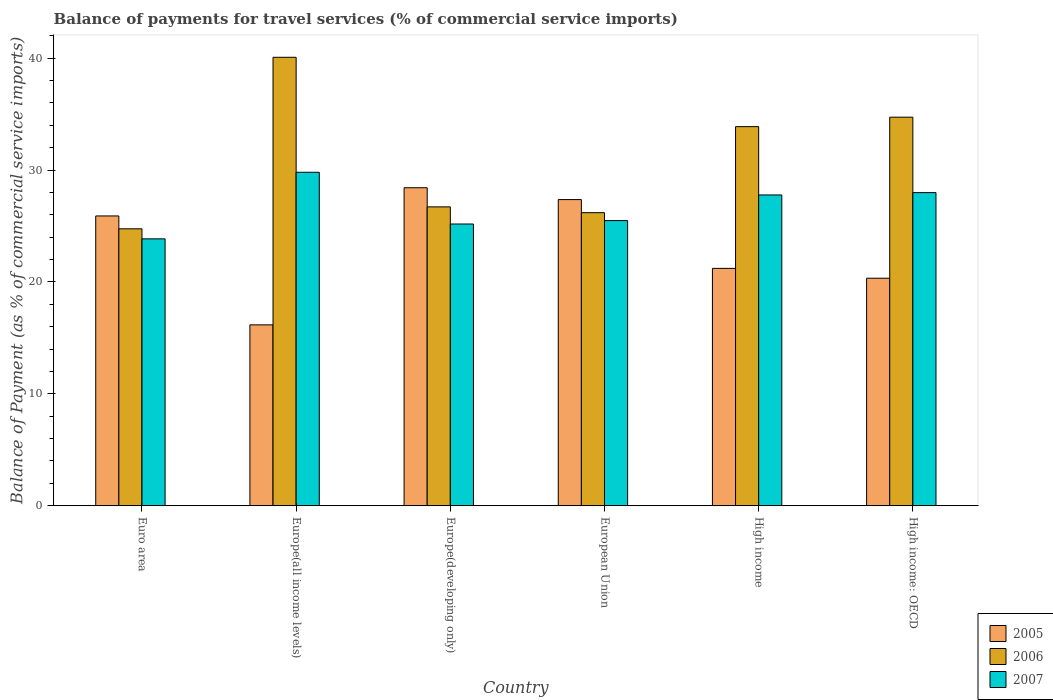How many groups of bars are there?
Give a very brief answer. 6. What is the label of the 5th group of bars from the left?
Make the answer very short. High income. What is the balance of payments for travel services in 2006 in Euro area?
Ensure brevity in your answer.  24.75. Across all countries, what is the maximum balance of payments for travel services in 2005?
Your response must be concise. 28.42. Across all countries, what is the minimum balance of payments for travel services in 2005?
Your response must be concise. 16.16. In which country was the balance of payments for travel services in 2006 maximum?
Make the answer very short. Europe(all income levels). In which country was the balance of payments for travel services in 2007 minimum?
Your response must be concise. Euro area. What is the total balance of payments for travel services in 2006 in the graph?
Provide a short and direct response. 186.31. What is the difference between the balance of payments for travel services in 2006 in Euro area and that in European Union?
Your answer should be very brief. -1.44. What is the difference between the balance of payments for travel services in 2006 in High income: OECD and the balance of payments for travel services in 2007 in Europe(all income levels)?
Your answer should be compact. 4.92. What is the average balance of payments for travel services in 2007 per country?
Give a very brief answer. 26.67. What is the difference between the balance of payments for travel services of/in 2006 and balance of payments for travel services of/in 2005 in Europe(all income levels)?
Your response must be concise. 23.91. What is the ratio of the balance of payments for travel services in 2005 in Europe(developing only) to that in High income: OECD?
Provide a succinct answer. 1.4. What is the difference between the highest and the second highest balance of payments for travel services in 2007?
Provide a succinct answer. -0.21. What is the difference between the highest and the lowest balance of payments for travel services in 2007?
Ensure brevity in your answer.  5.95. What does the 1st bar from the left in High income represents?
Your answer should be compact. 2005. How many bars are there?
Your response must be concise. 18. How many countries are there in the graph?
Your answer should be very brief. 6. What is the difference between two consecutive major ticks on the Y-axis?
Your response must be concise. 10. Are the values on the major ticks of Y-axis written in scientific E-notation?
Your response must be concise. No. Does the graph contain grids?
Provide a succinct answer. No. What is the title of the graph?
Your response must be concise. Balance of payments for travel services (% of commercial service imports). Does "1995" appear as one of the legend labels in the graph?
Your response must be concise. No. What is the label or title of the X-axis?
Your response must be concise. Country. What is the label or title of the Y-axis?
Your answer should be compact. Balance of Payment (as % of commercial service imports). What is the Balance of Payment (as % of commercial service imports) in 2005 in Euro area?
Offer a terse response. 25.89. What is the Balance of Payment (as % of commercial service imports) of 2006 in Euro area?
Your answer should be very brief. 24.75. What is the Balance of Payment (as % of commercial service imports) in 2007 in Euro area?
Make the answer very short. 23.85. What is the Balance of Payment (as % of commercial service imports) of 2005 in Europe(all income levels)?
Provide a succinct answer. 16.16. What is the Balance of Payment (as % of commercial service imports) in 2006 in Europe(all income levels)?
Make the answer very short. 40.07. What is the Balance of Payment (as % of commercial service imports) of 2007 in Europe(all income levels)?
Provide a short and direct response. 29.8. What is the Balance of Payment (as % of commercial service imports) in 2005 in Europe(developing only)?
Your response must be concise. 28.42. What is the Balance of Payment (as % of commercial service imports) in 2006 in Europe(developing only)?
Make the answer very short. 26.71. What is the Balance of Payment (as % of commercial service imports) in 2007 in Europe(developing only)?
Keep it short and to the point. 25.17. What is the Balance of Payment (as % of commercial service imports) in 2005 in European Union?
Your answer should be compact. 27.36. What is the Balance of Payment (as % of commercial service imports) in 2006 in European Union?
Offer a terse response. 26.19. What is the Balance of Payment (as % of commercial service imports) in 2007 in European Union?
Provide a succinct answer. 25.48. What is the Balance of Payment (as % of commercial service imports) in 2005 in High income?
Keep it short and to the point. 21.21. What is the Balance of Payment (as % of commercial service imports) of 2006 in High income?
Make the answer very short. 33.88. What is the Balance of Payment (as % of commercial service imports) in 2007 in High income?
Your response must be concise. 27.77. What is the Balance of Payment (as % of commercial service imports) of 2005 in High income: OECD?
Ensure brevity in your answer.  20.33. What is the Balance of Payment (as % of commercial service imports) of 2006 in High income: OECD?
Ensure brevity in your answer.  34.72. What is the Balance of Payment (as % of commercial service imports) of 2007 in High income: OECD?
Offer a terse response. 27.98. Across all countries, what is the maximum Balance of Payment (as % of commercial service imports) in 2005?
Your answer should be very brief. 28.42. Across all countries, what is the maximum Balance of Payment (as % of commercial service imports) in 2006?
Offer a very short reply. 40.07. Across all countries, what is the maximum Balance of Payment (as % of commercial service imports) in 2007?
Your answer should be compact. 29.8. Across all countries, what is the minimum Balance of Payment (as % of commercial service imports) of 2005?
Ensure brevity in your answer.  16.16. Across all countries, what is the minimum Balance of Payment (as % of commercial service imports) of 2006?
Give a very brief answer. 24.75. Across all countries, what is the minimum Balance of Payment (as % of commercial service imports) in 2007?
Offer a very short reply. 23.85. What is the total Balance of Payment (as % of commercial service imports) in 2005 in the graph?
Make the answer very short. 139.37. What is the total Balance of Payment (as % of commercial service imports) of 2006 in the graph?
Offer a very short reply. 186.31. What is the total Balance of Payment (as % of commercial service imports) in 2007 in the graph?
Provide a succinct answer. 160.05. What is the difference between the Balance of Payment (as % of commercial service imports) of 2005 in Euro area and that in Europe(all income levels)?
Give a very brief answer. 9.73. What is the difference between the Balance of Payment (as % of commercial service imports) of 2006 in Euro area and that in Europe(all income levels)?
Your response must be concise. -15.33. What is the difference between the Balance of Payment (as % of commercial service imports) in 2007 in Euro area and that in Europe(all income levels)?
Provide a short and direct response. -5.95. What is the difference between the Balance of Payment (as % of commercial service imports) in 2005 in Euro area and that in Europe(developing only)?
Offer a very short reply. -2.52. What is the difference between the Balance of Payment (as % of commercial service imports) in 2006 in Euro area and that in Europe(developing only)?
Your answer should be very brief. -1.96. What is the difference between the Balance of Payment (as % of commercial service imports) in 2007 in Euro area and that in Europe(developing only)?
Provide a succinct answer. -1.33. What is the difference between the Balance of Payment (as % of commercial service imports) in 2005 in Euro area and that in European Union?
Your answer should be very brief. -1.46. What is the difference between the Balance of Payment (as % of commercial service imports) of 2006 in Euro area and that in European Union?
Give a very brief answer. -1.44. What is the difference between the Balance of Payment (as % of commercial service imports) in 2007 in Euro area and that in European Union?
Your response must be concise. -1.63. What is the difference between the Balance of Payment (as % of commercial service imports) of 2005 in Euro area and that in High income?
Your response must be concise. 4.68. What is the difference between the Balance of Payment (as % of commercial service imports) in 2006 in Euro area and that in High income?
Provide a succinct answer. -9.13. What is the difference between the Balance of Payment (as % of commercial service imports) in 2007 in Euro area and that in High income?
Your answer should be very brief. -3.92. What is the difference between the Balance of Payment (as % of commercial service imports) in 2005 in Euro area and that in High income: OECD?
Give a very brief answer. 5.56. What is the difference between the Balance of Payment (as % of commercial service imports) in 2006 in Euro area and that in High income: OECD?
Ensure brevity in your answer.  -9.97. What is the difference between the Balance of Payment (as % of commercial service imports) of 2007 in Euro area and that in High income: OECD?
Your answer should be compact. -4.13. What is the difference between the Balance of Payment (as % of commercial service imports) in 2005 in Europe(all income levels) and that in Europe(developing only)?
Give a very brief answer. -12.25. What is the difference between the Balance of Payment (as % of commercial service imports) of 2006 in Europe(all income levels) and that in Europe(developing only)?
Ensure brevity in your answer.  13.37. What is the difference between the Balance of Payment (as % of commercial service imports) in 2007 in Europe(all income levels) and that in Europe(developing only)?
Ensure brevity in your answer.  4.62. What is the difference between the Balance of Payment (as % of commercial service imports) of 2005 in Europe(all income levels) and that in European Union?
Make the answer very short. -11.2. What is the difference between the Balance of Payment (as % of commercial service imports) of 2006 in Europe(all income levels) and that in European Union?
Provide a succinct answer. 13.88. What is the difference between the Balance of Payment (as % of commercial service imports) in 2007 in Europe(all income levels) and that in European Union?
Your answer should be very brief. 4.32. What is the difference between the Balance of Payment (as % of commercial service imports) of 2005 in Europe(all income levels) and that in High income?
Make the answer very short. -5.05. What is the difference between the Balance of Payment (as % of commercial service imports) in 2006 in Europe(all income levels) and that in High income?
Offer a very short reply. 6.2. What is the difference between the Balance of Payment (as % of commercial service imports) in 2007 in Europe(all income levels) and that in High income?
Make the answer very short. 2.03. What is the difference between the Balance of Payment (as % of commercial service imports) of 2005 in Europe(all income levels) and that in High income: OECD?
Keep it short and to the point. -4.17. What is the difference between the Balance of Payment (as % of commercial service imports) of 2006 in Europe(all income levels) and that in High income: OECD?
Make the answer very short. 5.35. What is the difference between the Balance of Payment (as % of commercial service imports) in 2007 in Europe(all income levels) and that in High income: OECD?
Provide a succinct answer. 1.82. What is the difference between the Balance of Payment (as % of commercial service imports) in 2005 in Europe(developing only) and that in European Union?
Your answer should be compact. 1.06. What is the difference between the Balance of Payment (as % of commercial service imports) of 2006 in Europe(developing only) and that in European Union?
Give a very brief answer. 0.52. What is the difference between the Balance of Payment (as % of commercial service imports) of 2007 in Europe(developing only) and that in European Union?
Offer a terse response. -0.31. What is the difference between the Balance of Payment (as % of commercial service imports) in 2005 in Europe(developing only) and that in High income?
Your answer should be very brief. 7.21. What is the difference between the Balance of Payment (as % of commercial service imports) in 2006 in Europe(developing only) and that in High income?
Make the answer very short. -7.17. What is the difference between the Balance of Payment (as % of commercial service imports) of 2007 in Europe(developing only) and that in High income?
Your response must be concise. -2.6. What is the difference between the Balance of Payment (as % of commercial service imports) of 2005 in Europe(developing only) and that in High income: OECD?
Provide a succinct answer. 8.08. What is the difference between the Balance of Payment (as % of commercial service imports) in 2006 in Europe(developing only) and that in High income: OECD?
Offer a terse response. -8.01. What is the difference between the Balance of Payment (as % of commercial service imports) in 2007 in Europe(developing only) and that in High income: OECD?
Provide a succinct answer. -2.8. What is the difference between the Balance of Payment (as % of commercial service imports) of 2005 in European Union and that in High income?
Provide a succinct answer. 6.15. What is the difference between the Balance of Payment (as % of commercial service imports) of 2006 in European Union and that in High income?
Offer a very short reply. -7.69. What is the difference between the Balance of Payment (as % of commercial service imports) in 2007 in European Union and that in High income?
Make the answer very short. -2.29. What is the difference between the Balance of Payment (as % of commercial service imports) in 2005 in European Union and that in High income: OECD?
Ensure brevity in your answer.  7.03. What is the difference between the Balance of Payment (as % of commercial service imports) in 2006 in European Union and that in High income: OECD?
Your answer should be compact. -8.53. What is the difference between the Balance of Payment (as % of commercial service imports) of 2007 in European Union and that in High income: OECD?
Offer a very short reply. -2.5. What is the difference between the Balance of Payment (as % of commercial service imports) in 2005 in High income and that in High income: OECD?
Provide a succinct answer. 0.88. What is the difference between the Balance of Payment (as % of commercial service imports) of 2006 in High income and that in High income: OECD?
Ensure brevity in your answer.  -0.84. What is the difference between the Balance of Payment (as % of commercial service imports) in 2007 in High income and that in High income: OECD?
Your response must be concise. -0.21. What is the difference between the Balance of Payment (as % of commercial service imports) of 2005 in Euro area and the Balance of Payment (as % of commercial service imports) of 2006 in Europe(all income levels)?
Ensure brevity in your answer.  -14.18. What is the difference between the Balance of Payment (as % of commercial service imports) in 2005 in Euro area and the Balance of Payment (as % of commercial service imports) in 2007 in Europe(all income levels)?
Give a very brief answer. -3.9. What is the difference between the Balance of Payment (as % of commercial service imports) in 2006 in Euro area and the Balance of Payment (as % of commercial service imports) in 2007 in Europe(all income levels)?
Your answer should be compact. -5.05. What is the difference between the Balance of Payment (as % of commercial service imports) of 2005 in Euro area and the Balance of Payment (as % of commercial service imports) of 2006 in Europe(developing only)?
Offer a very short reply. -0.81. What is the difference between the Balance of Payment (as % of commercial service imports) in 2005 in Euro area and the Balance of Payment (as % of commercial service imports) in 2007 in Europe(developing only)?
Offer a terse response. 0.72. What is the difference between the Balance of Payment (as % of commercial service imports) of 2006 in Euro area and the Balance of Payment (as % of commercial service imports) of 2007 in Europe(developing only)?
Your response must be concise. -0.43. What is the difference between the Balance of Payment (as % of commercial service imports) in 2005 in Euro area and the Balance of Payment (as % of commercial service imports) in 2006 in European Union?
Make the answer very short. -0.29. What is the difference between the Balance of Payment (as % of commercial service imports) in 2005 in Euro area and the Balance of Payment (as % of commercial service imports) in 2007 in European Union?
Your answer should be compact. 0.41. What is the difference between the Balance of Payment (as % of commercial service imports) in 2006 in Euro area and the Balance of Payment (as % of commercial service imports) in 2007 in European Union?
Provide a succinct answer. -0.73. What is the difference between the Balance of Payment (as % of commercial service imports) of 2005 in Euro area and the Balance of Payment (as % of commercial service imports) of 2006 in High income?
Your answer should be compact. -7.98. What is the difference between the Balance of Payment (as % of commercial service imports) of 2005 in Euro area and the Balance of Payment (as % of commercial service imports) of 2007 in High income?
Make the answer very short. -1.88. What is the difference between the Balance of Payment (as % of commercial service imports) in 2006 in Euro area and the Balance of Payment (as % of commercial service imports) in 2007 in High income?
Keep it short and to the point. -3.02. What is the difference between the Balance of Payment (as % of commercial service imports) of 2005 in Euro area and the Balance of Payment (as % of commercial service imports) of 2006 in High income: OECD?
Provide a succinct answer. -8.83. What is the difference between the Balance of Payment (as % of commercial service imports) in 2005 in Euro area and the Balance of Payment (as % of commercial service imports) in 2007 in High income: OECD?
Your response must be concise. -2.09. What is the difference between the Balance of Payment (as % of commercial service imports) in 2006 in Euro area and the Balance of Payment (as % of commercial service imports) in 2007 in High income: OECD?
Provide a short and direct response. -3.23. What is the difference between the Balance of Payment (as % of commercial service imports) in 2005 in Europe(all income levels) and the Balance of Payment (as % of commercial service imports) in 2006 in Europe(developing only)?
Your response must be concise. -10.55. What is the difference between the Balance of Payment (as % of commercial service imports) of 2005 in Europe(all income levels) and the Balance of Payment (as % of commercial service imports) of 2007 in Europe(developing only)?
Offer a terse response. -9.01. What is the difference between the Balance of Payment (as % of commercial service imports) in 2006 in Europe(all income levels) and the Balance of Payment (as % of commercial service imports) in 2007 in Europe(developing only)?
Offer a very short reply. 14.9. What is the difference between the Balance of Payment (as % of commercial service imports) in 2005 in Europe(all income levels) and the Balance of Payment (as % of commercial service imports) in 2006 in European Union?
Provide a succinct answer. -10.03. What is the difference between the Balance of Payment (as % of commercial service imports) in 2005 in Europe(all income levels) and the Balance of Payment (as % of commercial service imports) in 2007 in European Union?
Offer a very short reply. -9.32. What is the difference between the Balance of Payment (as % of commercial service imports) of 2006 in Europe(all income levels) and the Balance of Payment (as % of commercial service imports) of 2007 in European Union?
Provide a succinct answer. 14.59. What is the difference between the Balance of Payment (as % of commercial service imports) in 2005 in Europe(all income levels) and the Balance of Payment (as % of commercial service imports) in 2006 in High income?
Your answer should be compact. -17.71. What is the difference between the Balance of Payment (as % of commercial service imports) in 2005 in Europe(all income levels) and the Balance of Payment (as % of commercial service imports) in 2007 in High income?
Offer a very short reply. -11.61. What is the difference between the Balance of Payment (as % of commercial service imports) in 2006 in Europe(all income levels) and the Balance of Payment (as % of commercial service imports) in 2007 in High income?
Give a very brief answer. 12.3. What is the difference between the Balance of Payment (as % of commercial service imports) in 2005 in Europe(all income levels) and the Balance of Payment (as % of commercial service imports) in 2006 in High income: OECD?
Make the answer very short. -18.56. What is the difference between the Balance of Payment (as % of commercial service imports) in 2005 in Europe(all income levels) and the Balance of Payment (as % of commercial service imports) in 2007 in High income: OECD?
Ensure brevity in your answer.  -11.82. What is the difference between the Balance of Payment (as % of commercial service imports) of 2006 in Europe(all income levels) and the Balance of Payment (as % of commercial service imports) of 2007 in High income: OECD?
Your answer should be compact. 12.09. What is the difference between the Balance of Payment (as % of commercial service imports) in 2005 in Europe(developing only) and the Balance of Payment (as % of commercial service imports) in 2006 in European Union?
Your response must be concise. 2.23. What is the difference between the Balance of Payment (as % of commercial service imports) in 2005 in Europe(developing only) and the Balance of Payment (as % of commercial service imports) in 2007 in European Union?
Your response must be concise. 2.94. What is the difference between the Balance of Payment (as % of commercial service imports) of 2006 in Europe(developing only) and the Balance of Payment (as % of commercial service imports) of 2007 in European Union?
Offer a very short reply. 1.23. What is the difference between the Balance of Payment (as % of commercial service imports) of 2005 in Europe(developing only) and the Balance of Payment (as % of commercial service imports) of 2006 in High income?
Keep it short and to the point. -5.46. What is the difference between the Balance of Payment (as % of commercial service imports) in 2005 in Europe(developing only) and the Balance of Payment (as % of commercial service imports) in 2007 in High income?
Make the answer very short. 0.65. What is the difference between the Balance of Payment (as % of commercial service imports) of 2006 in Europe(developing only) and the Balance of Payment (as % of commercial service imports) of 2007 in High income?
Make the answer very short. -1.06. What is the difference between the Balance of Payment (as % of commercial service imports) of 2005 in Europe(developing only) and the Balance of Payment (as % of commercial service imports) of 2006 in High income: OECD?
Ensure brevity in your answer.  -6.3. What is the difference between the Balance of Payment (as % of commercial service imports) in 2005 in Europe(developing only) and the Balance of Payment (as % of commercial service imports) in 2007 in High income: OECD?
Give a very brief answer. 0.44. What is the difference between the Balance of Payment (as % of commercial service imports) in 2006 in Europe(developing only) and the Balance of Payment (as % of commercial service imports) in 2007 in High income: OECD?
Your answer should be very brief. -1.27. What is the difference between the Balance of Payment (as % of commercial service imports) in 2005 in European Union and the Balance of Payment (as % of commercial service imports) in 2006 in High income?
Make the answer very short. -6.52. What is the difference between the Balance of Payment (as % of commercial service imports) of 2005 in European Union and the Balance of Payment (as % of commercial service imports) of 2007 in High income?
Offer a terse response. -0.41. What is the difference between the Balance of Payment (as % of commercial service imports) of 2006 in European Union and the Balance of Payment (as % of commercial service imports) of 2007 in High income?
Provide a short and direct response. -1.58. What is the difference between the Balance of Payment (as % of commercial service imports) of 2005 in European Union and the Balance of Payment (as % of commercial service imports) of 2006 in High income: OECD?
Provide a short and direct response. -7.36. What is the difference between the Balance of Payment (as % of commercial service imports) in 2005 in European Union and the Balance of Payment (as % of commercial service imports) in 2007 in High income: OECD?
Keep it short and to the point. -0.62. What is the difference between the Balance of Payment (as % of commercial service imports) of 2006 in European Union and the Balance of Payment (as % of commercial service imports) of 2007 in High income: OECD?
Your response must be concise. -1.79. What is the difference between the Balance of Payment (as % of commercial service imports) in 2005 in High income and the Balance of Payment (as % of commercial service imports) in 2006 in High income: OECD?
Your answer should be compact. -13.51. What is the difference between the Balance of Payment (as % of commercial service imports) in 2005 in High income and the Balance of Payment (as % of commercial service imports) in 2007 in High income: OECD?
Your response must be concise. -6.77. What is the difference between the Balance of Payment (as % of commercial service imports) in 2006 in High income and the Balance of Payment (as % of commercial service imports) in 2007 in High income: OECD?
Offer a terse response. 5.9. What is the average Balance of Payment (as % of commercial service imports) in 2005 per country?
Keep it short and to the point. 23.23. What is the average Balance of Payment (as % of commercial service imports) in 2006 per country?
Your answer should be very brief. 31.05. What is the average Balance of Payment (as % of commercial service imports) in 2007 per country?
Ensure brevity in your answer.  26.67. What is the difference between the Balance of Payment (as % of commercial service imports) in 2005 and Balance of Payment (as % of commercial service imports) in 2006 in Euro area?
Offer a very short reply. 1.15. What is the difference between the Balance of Payment (as % of commercial service imports) of 2005 and Balance of Payment (as % of commercial service imports) of 2007 in Euro area?
Your answer should be compact. 2.05. What is the difference between the Balance of Payment (as % of commercial service imports) of 2006 and Balance of Payment (as % of commercial service imports) of 2007 in Euro area?
Offer a very short reply. 0.9. What is the difference between the Balance of Payment (as % of commercial service imports) of 2005 and Balance of Payment (as % of commercial service imports) of 2006 in Europe(all income levels)?
Keep it short and to the point. -23.91. What is the difference between the Balance of Payment (as % of commercial service imports) of 2005 and Balance of Payment (as % of commercial service imports) of 2007 in Europe(all income levels)?
Your response must be concise. -13.64. What is the difference between the Balance of Payment (as % of commercial service imports) of 2006 and Balance of Payment (as % of commercial service imports) of 2007 in Europe(all income levels)?
Make the answer very short. 10.27. What is the difference between the Balance of Payment (as % of commercial service imports) of 2005 and Balance of Payment (as % of commercial service imports) of 2006 in Europe(developing only)?
Your response must be concise. 1.71. What is the difference between the Balance of Payment (as % of commercial service imports) of 2005 and Balance of Payment (as % of commercial service imports) of 2007 in Europe(developing only)?
Provide a short and direct response. 3.24. What is the difference between the Balance of Payment (as % of commercial service imports) of 2006 and Balance of Payment (as % of commercial service imports) of 2007 in Europe(developing only)?
Keep it short and to the point. 1.53. What is the difference between the Balance of Payment (as % of commercial service imports) in 2005 and Balance of Payment (as % of commercial service imports) in 2006 in European Union?
Make the answer very short. 1.17. What is the difference between the Balance of Payment (as % of commercial service imports) in 2005 and Balance of Payment (as % of commercial service imports) in 2007 in European Union?
Offer a terse response. 1.88. What is the difference between the Balance of Payment (as % of commercial service imports) of 2006 and Balance of Payment (as % of commercial service imports) of 2007 in European Union?
Make the answer very short. 0.71. What is the difference between the Balance of Payment (as % of commercial service imports) of 2005 and Balance of Payment (as % of commercial service imports) of 2006 in High income?
Your answer should be compact. -12.67. What is the difference between the Balance of Payment (as % of commercial service imports) in 2005 and Balance of Payment (as % of commercial service imports) in 2007 in High income?
Provide a succinct answer. -6.56. What is the difference between the Balance of Payment (as % of commercial service imports) in 2006 and Balance of Payment (as % of commercial service imports) in 2007 in High income?
Provide a short and direct response. 6.11. What is the difference between the Balance of Payment (as % of commercial service imports) of 2005 and Balance of Payment (as % of commercial service imports) of 2006 in High income: OECD?
Give a very brief answer. -14.39. What is the difference between the Balance of Payment (as % of commercial service imports) of 2005 and Balance of Payment (as % of commercial service imports) of 2007 in High income: OECD?
Make the answer very short. -7.65. What is the difference between the Balance of Payment (as % of commercial service imports) in 2006 and Balance of Payment (as % of commercial service imports) in 2007 in High income: OECD?
Keep it short and to the point. 6.74. What is the ratio of the Balance of Payment (as % of commercial service imports) in 2005 in Euro area to that in Europe(all income levels)?
Your answer should be very brief. 1.6. What is the ratio of the Balance of Payment (as % of commercial service imports) in 2006 in Euro area to that in Europe(all income levels)?
Provide a succinct answer. 0.62. What is the ratio of the Balance of Payment (as % of commercial service imports) in 2007 in Euro area to that in Europe(all income levels)?
Give a very brief answer. 0.8. What is the ratio of the Balance of Payment (as % of commercial service imports) of 2005 in Euro area to that in Europe(developing only)?
Give a very brief answer. 0.91. What is the ratio of the Balance of Payment (as % of commercial service imports) of 2006 in Euro area to that in Europe(developing only)?
Give a very brief answer. 0.93. What is the ratio of the Balance of Payment (as % of commercial service imports) of 2007 in Euro area to that in Europe(developing only)?
Offer a terse response. 0.95. What is the ratio of the Balance of Payment (as % of commercial service imports) in 2005 in Euro area to that in European Union?
Give a very brief answer. 0.95. What is the ratio of the Balance of Payment (as % of commercial service imports) in 2006 in Euro area to that in European Union?
Provide a short and direct response. 0.94. What is the ratio of the Balance of Payment (as % of commercial service imports) in 2007 in Euro area to that in European Union?
Provide a short and direct response. 0.94. What is the ratio of the Balance of Payment (as % of commercial service imports) of 2005 in Euro area to that in High income?
Ensure brevity in your answer.  1.22. What is the ratio of the Balance of Payment (as % of commercial service imports) of 2006 in Euro area to that in High income?
Your answer should be very brief. 0.73. What is the ratio of the Balance of Payment (as % of commercial service imports) of 2007 in Euro area to that in High income?
Your response must be concise. 0.86. What is the ratio of the Balance of Payment (as % of commercial service imports) in 2005 in Euro area to that in High income: OECD?
Your response must be concise. 1.27. What is the ratio of the Balance of Payment (as % of commercial service imports) of 2006 in Euro area to that in High income: OECD?
Provide a succinct answer. 0.71. What is the ratio of the Balance of Payment (as % of commercial service imports) in 2007 in Euro area to that in High income: OECD?
Your answer should be very brief. 0.85. What is the ratio of the Balance of Payment (as % of commercial service imports) in 2005 in Europe(all income levels) to that in Europe(developing only)?
Ensure brevity in your answer.  0.57. What is the ratio of the Balance of Payment (as % of commercial service imports) of 2006 in Europe(all income levels) to that in Europe(developing only)?
Provide a short and direct response. 1.5. What is the ratio of the Balance of Payment (as % of commercial service imports) of 2007 in Europe(all income levels) to that in Europe(developing only)?
Offer a terse response. 1.18. What is the ratio of the Balance of Payment (as % of commercial service imports) of 2005 in Europe(all income levels) to that in European Union?
Provide a succinct answer. 0.59. What is the ratio of the Balance of Payment (as % of commercial service imports) in 2006 in Europe(all income levels) to that in European Union?
Provide a succinct answer. 1.53. What is the ratio of the Balance of Payment (as % of commercial service imports) in 2007 in Europe(all income levels) to that in European Union?
Your answer should be very brief. 1.17. What is the ratio of the Balance of Payment (as % of commercial service imports) in 2005 in Europe(all income levels) to that in High income?
Offer a terse response. 0.76. What is the ratio of the Balance of Payment (as % of commercial service imports) in 2006 in Europe(all income levels) to that in High income?
Give a very brief answer. 1.18. What is the ratio of the Balance of Payment (as % of commercial service imports) of 2007 in Europe(all income levels) to that in High income?
Your answer should be compact. 1.07. What is the ratio of the Balance of Payment (as % of commercial service imports) in 2005 in Europe(all income levels) to that in High income: OECD?
Ensure brevity in your answer.  0.79. What is the ratio of the Balance of Payment (as % of commercial service imports) in 2006 in Europe(all income levels) to that in High income: OECD?
Ensure brevity in your answer.  1.15. What is the ratio of the Balance of Payment (as % of commercial service imports) in 2007 in Europe(all income levels) to that in High income: OECD?
Offer a very short reply. 1.06. What is the ratio of the Balance of Payment (as % of commercial service imports) in 2005 in Europe(developing only) to that in European Union?
Keep it short and to the point. 1.04. What is the ratio of the Balance of Payment (as % of commercial service imports) of 2006 in Europe(developing only) to that in European Union?
Your answer should be very brief. 1.02. What is the ratio of the Balance of Payment (as % of commercial service imports) of 2007 in Europe(developing only) to that in European Union?
Keep it short and to the point. 0.99. What is the ratio of the Balance of Payment (as % of commercial service imports) in 2005 in Europe(developing only) to that in High income?
Ensure brevity in your answer.  1.34. What is the ratio of the Balance of Payment (as % of commercial service imports) in 2006 in Europe(developing only) to that in High income?
Provide a succinct answer. 0.79. What is the ratio of the Balance of Payment (as % of commercial service imports) of 2007 in Europe(developing only) to that in High income?
Keep it short and to the point. 0.91. What is the ratio of the Balance of Payment (as % of commercial service imports) in 2005 in Europe(developing only) to that in High income: OECD?
Keep it short and to the point. 1.4. What is the ratio of the Balance of Payment (as % of commercial service imports) in 2006 in Europe(developing only) to that in High income: OECD?
Provide a short and direct response. 0.77. What is the ratio of the Balance of Payment (as % of commercial service imports) of 2007 in Europe(developing only) to that in High income: OECD?
Ensure brevity in your answer.  0.9. What is the ratio of the Balance of Payment (as % of commercial service imports) of 2005 in European Union to that in High income?
Your answer should be compact. 1.29. What is the ratio of the Balance of Payment (as % of commercial service imports) in 2006 in European Union to that in High income?
Offer a terse response. 0.77. What is the ratio of the Balance of Payment (as % of commercial service imports) of 2007 in European Union to that in High income?
Give a very brief answer. 0.92. What is the ratio of the Balance of Payment (as % of commercial service imports) of 2005 in European Union to that in High income: OECD?
Your answer should be compact. 1.35. What is the ratio of the Balance of Payment (as % of commercial service imports) in 2006 in European Union to that in High income: OECD?
Your answer should be compact. 0.75. What is the ratio of the Balance of Payment (as % of commercial service imports) in 2007 in European Union to that in High income: OECD?
Your answer should be compact. 0.91. What is the ratio of the Balance of Payment (as % of commercial service imports) of 2005 in High income to that in High income: OECD?
Keep it short and to the point. 1.04. What is the ratio of the Balance of Payment (as % of commercial service imports) of 2006 in High income to that in High income: OECD?
Your answer should be very brief. 0.98. What is the difference between the highest and the second highest Balance of Payment (as % of commercial service imports) in 2005?
Provide a succinct answer. 1.06. What is the difference between the highest and the second highest Balance of Payment (as % of commercial service imports) in 2006?
Your answer should be very brief. 5.35. What is the difference between the highest and the second highest Balance of Payment (as % of commercial service imports) in 2007?
Provide a short and direct response. 1.82. What is the difference between the highest and the lowest Balance of Payment (as % of commercial service imports) in 2005?
Provide a short and direct response. 12.25. What is the difference between the highest and the lowest Balance of Payment (as % of commercial service imports) of 2006?
Your response must be concise. 15.33. What is the difference between the highest and the lowest Balance of Payment (as % of commercial service imports) in 2007?
Keep it short and to the point. 5.95. 